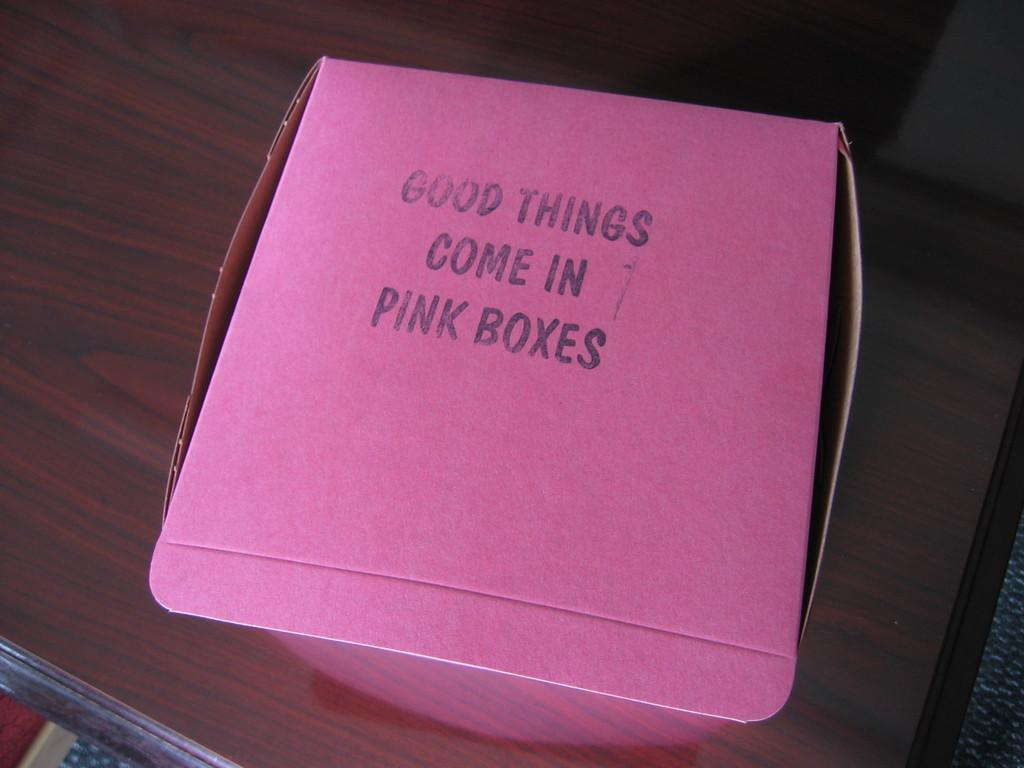<image>
Give a short and clear explanation of the subsequent image. A pink box on which is written: "Good Things Come in Pink Boxes". 